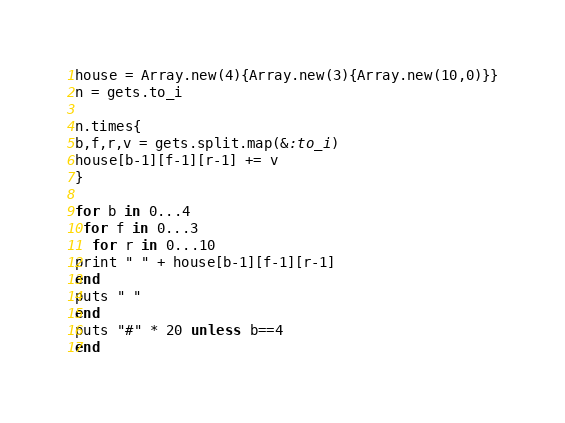<code> <loc_0><loc_0><loc_500><loc_500><_Ruby_>house = Array.new(4){Array.new(3){Array.new(10,0)}}
n = gets.to_i

n.times{
b,f,r,v = gets.split.map(&:to_i)
house[b-1][f-1][r-1] += v
}

for b in 0...4
 for f in 0...3
  for r in 0...10
print " " + house[b-1][f-1][r-1]
end
puts " "
end
puts "#" * 20 unless b==4
end
</code> 